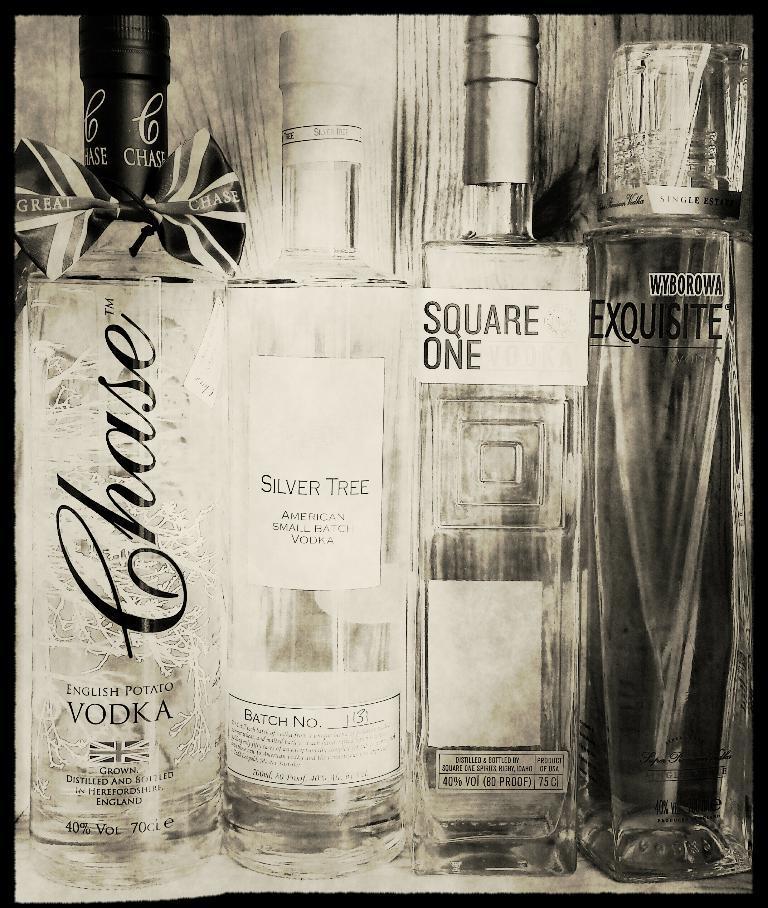Could you give a brief overview of what you see in this image? In this picture there are four bottles , they are English potato vodka ,silver tree , square one and Equiste. Among them English potato vodka is beautifully designed. 